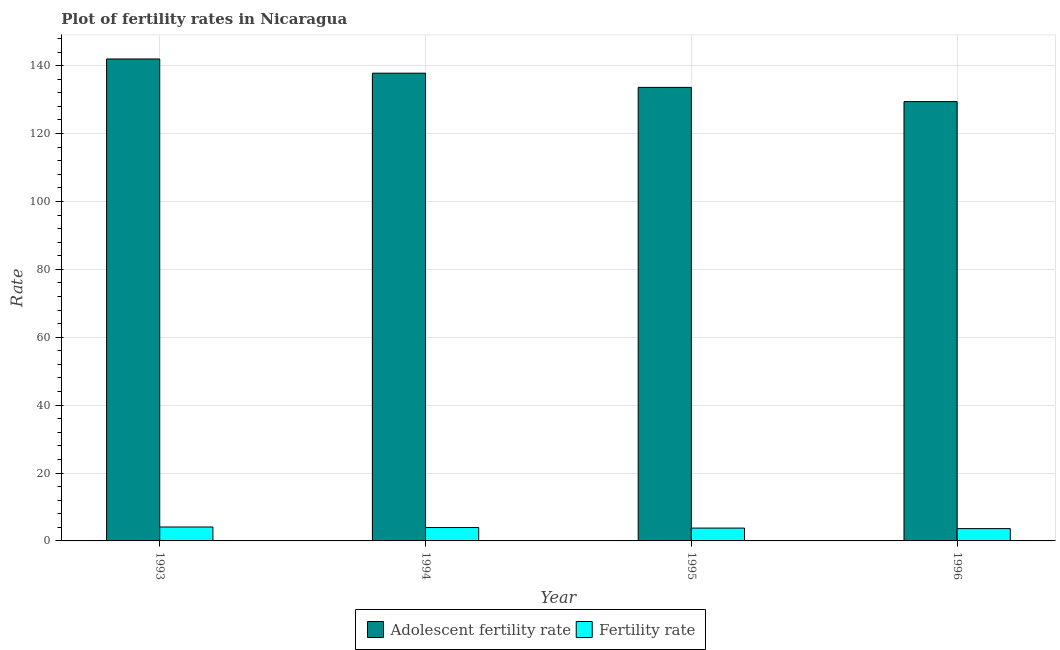How many different coloured bars are there?
Make the answer very short. 2. How many bars are there on the 2nd tick from the left?
Ensure brevity in your answer.  2. What is the fertility rate in 1994?
Your answer should be compact. 3.94. Across all years, what is the maximum adolescent fertility rate?
Your answer should be compact. 141.97. Across all years, what is the minimum fertility rate?
Offer a terse response. 3.62. In which year was the adolescent fertility rate maximum?
Offer a very short reply. 1993. What is the total adolescent fertility rate in the graph?
Your answer should be compact. 542.79. What is the difference between the fertility rate in 1993 and that in 1995?
Give a very brief answer. 0.33. What is the difference between the adolescent fertility rate in 1996 and the fertility rate in 1995?
Provide a short and direct response. -4.19. What is the average adolescent fertility rate per year?
Ensure brevity in your answer.  135.7. In how many years, is the fertility rate greater than 24?
Your answer should be very brief. 0. What is the ratio of the fertility rate in 1993 to that in 1996?
Your answer should be very brief. 1.13. Is the fertility rate in 1993 less than that in 1994?
Provide a succinct answer. No. What is the difference between the highest and the second highest fertility rate?
Make the answer very short. 0.16. What is the difference between the highest and the lowest adolescent fertility rate?
Your answer should be very brief. 12.56. In how many years, is the fertility rate greater than the average fertility rate taken over all years?
Ensure brevity in your answer.  2. What does the 2nd bar from the left in 1996 represents?
Keep it short and to the point. Fertility rate. What does the 2nd bar from the right in 1994 represents?
Offer a terse response. Adolescent fertility rate. How many bars are there?
Keep it short and to the point. 8. Are all the bars in the graph horizontal?
Ensure brevity in your answer.  No. Are the values on the major ticks of Y-axis written in scientific E-notation?
Your answer should be very brief. No. Where does the legend appear in the graph?
Make the answer very short. Bottom center. What is the title of the graph?
Give a very brief answer. Plot of fertility rates in Nicaragua. What is the label or title of the X-axis?
Keep it short and to the point. Year. What is the label or title of the Y-axis?
Your answer should be very brief. Rate. What is the Rate of Adolescent fertility rate in 1993?
Make the answer very short. 141.97. What is the Rate of Fertility rate in 1993?
Provide a short and direct response. 4.11. What is the Rate in Adolescent fertility rate in 1994?
Your answer should be very brief. 137.79. What is the Rate in Fertility rate in 1994?
Make the answer very short. 3.94. What is the Rate of Adolescent fertility rate in 1995?
Make the answer very short. 133.6. What is the Rate in Fertility rate in 1995?
Your response must be concise. 3.78. What is the Rate in Adolescent fertility rate in 1996?
Your response must be concise. 129.42. What is the Rate in Fertility rate in 1996?
Your answer should be very brief. 3.62. Across all years, what is the maximum Rate in Adolescent fertility rate?
Offer a very short reply. 141.97. Across all years, what is the maximum Rate of Fertility rate?
Offer a very short reply. 4.11. Across all years, what is the minimum Rate in Adolescent fertility rate?
Ensure brevity in your answer.  129.42. Across all years, what is the minimum Rate in Fertility rate?
Your response must be concise. 3.62. What is the total Rate in Adolescent fertility rate in the graph?
Give a very brief answer. 542.79. What is the total Rate of Fertility rate in the graph?
Ensure brevity in your answer.  15.45. What is the difference between the Rate of Adolescent fertility rate in 1993 and that in 1994?
Provide a succinct answer. 4.19. What is the difference between the Rate of Fertility rate in 1993 and that in 1994?
Give a very brief answer. 0.16. What is the difference between the Rate of Adolescent fertility rate in 1993 and that in 1995?
Make the answer very short. 8.37. What is the difference between the Rate in Fertility rate in 1993 and that in 1995?
Offer a very short reply. 0.33. What is the difference between the Rate of Adolescent fertility rate in 1993 and that in 1996?
Keep it short and to the point. 12.56. What is the difference between the Rate in Fertility rate in 1993 and that in 1996?
Offer a terse response. 0.48. What is the difference between the Rate in Adolescent fertility rate in 1994 and that in 1995?
Your answer should be very brief. 4.19. What is the difference between the Rate in Fertility rate in 1994 and that in 1995?
Your answer should be very brief. 0.16. What is the difference between the Rate in Adolescent fertility rate in 1994 and that in 1996?
Your answer should be compact. 8.37. What is the difference between the Rate of Fertility rate in 1994 and that in 1996?
Give a very brief answer. 0.32. What is the difference between the Rate in Adolescent fertility rate in 1995 and that in 1996?
Provide a short and direct response. 4.19. What is the difference between the Rate in Fertility rate in 1995 and that in 1996?
Offer a very short reply. 0.16. What is the difference between the Rate in Adolescent fertility rate in 1993 and the Rate in Fertility rate in 1994?
Your answer should be very brief. 138.03. What is the difference between the Rate of Adolescent fertility rate in 1993 and the Rate of Fertility rate in 1995?
Provide a short and direct response. 138.19. What is the difference between the Rate in Adolescent fertility rate in 1993 and the Rate in Fertility rate in 1996?
Your answer should be compact. 138.35. What is the difference between the Rate of Adolescent fertility rate in 1994 and the Rate of Fertility rate in 1995?
Provide a succinct answer. 134.01. What is the difference between the Rate in Adolescent fertility rate in 1994 and the Rate in Fertility rate in 1996?
Keep it short and to the point. 134.17. What is the difference between the Rate in Adolescent fertility rate in 1995 and the Rate in Fertility rate in 1996?
Provide a short and direct response. 129.98. What is the average Rate in Adolescent fertility rate per year?
Offer a terse response. 135.7. What is the average Rate of Fertility rate per year?
Provide a succinct answer. 3.86. In the year 1993, what is the difference between the Rate of Adolescent fertility rate and Rate of Fertility rate?
Provide a succinct answer. 137.87. In the year 1994, what is the difference between the Rate of Adolescent fertility rate and Rate of Fertility rate?
Your answer should be very brief. 133.85. In the year 1995, what is the difference between the Rate in Adolescent fertility rate and Rate in Fertility rate?
Provide a succinct answer. 129.82. In the year 1996, what is the difference between the Rate of Adolescent fertility rate and Rate of Fertility rate?
Keep it short and to the point. 125.8. What is the ratio of the Rate of Adolescent fertility rate in 1993 to that in 1994?
Give a very brief answer. 1.03. What is the ratio of the Rate of Fertility rate in 1993 to that in 1994?
Offer a terse response. 1.04. What is the ratio of the Rate of Adolescent fertility rate in 1993 to that in 1995?
Your answer should be compact. 1.06. What is the ratio of the Rate of Fertility rate in 1993 to that in 1995?
Make the answer very short. 1.09. What is the ratio of the Rate in Adolescent fertility rate in 1993 to that in 1996?
Offer a very short reply. 1.1. What is the ratio of the Rate of Fertility rate in 1993 to that in 1996?
Offer a terse response. 1.13. What is the ratio of the Rate in Adolescent fertility rate in 1994 to that in 1995?
Offer a very short reply. 1.03. What is the ratio of the Rate in Fertility rate in 1994 to that in 1995?
Offer a terse response. 1.04. What is the ratio of the Rate in Adolescent fertility rate in 1994 to that in 1996?
Ensure brevity in your answer.  1.06. What is the ratio of the Rate in Fertility rate in 1994 to that in 1996?
Offer a very short reply. 1.09. What is the ratio of the Rate in Adolescent fertility rate in 1995 to that in 1996?
Provide a short and direct response. 1.03. What is the ratio of the Rate in Fertility rate in 1995 to that in 1996?
Provide a short and direct response. 1.04. What is the difference between the highest and the second highest Rate of Adolescent fertility rate?
Offer a terse response. 4.19. What is the difference between the highest and the second highest Rate in Fertility rate?
Provide a short and direct response. 0.16. What is the difference between the highest and the lowest Rate in Adolescent fertility rate?
Keep it short and to the point. 12.56. What is the difference between the highest and the lowest Rate of Fertility rate?
Offer a very short reply. 0.48. 